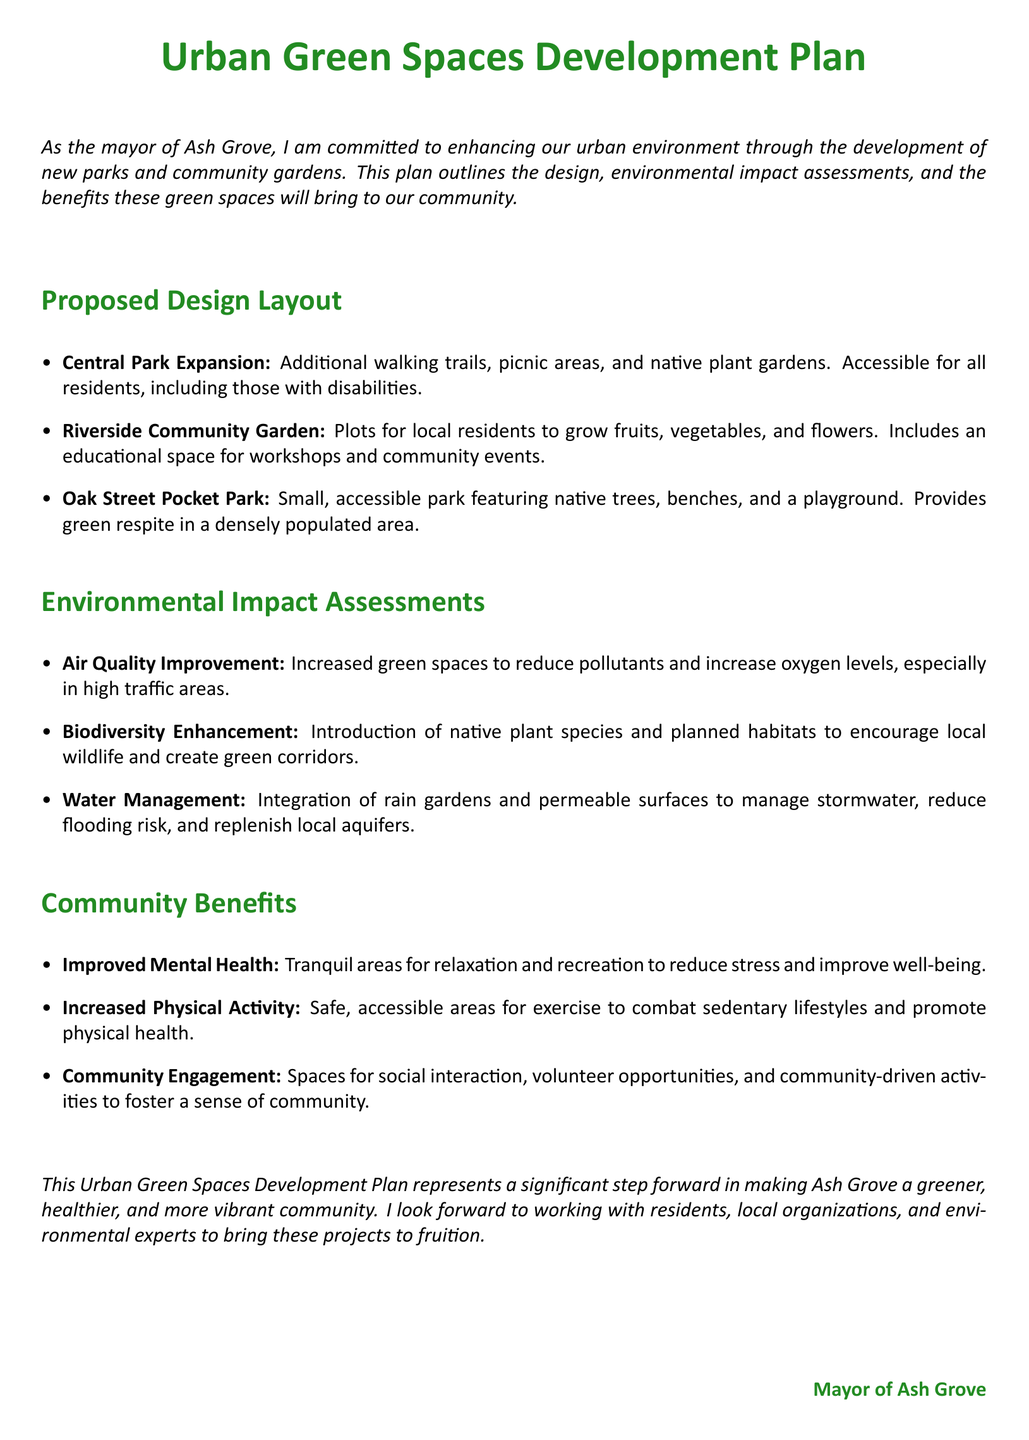What is the title of the document? The title is prominently displayed at the beginning, outlining the document's focus.
Answer: Urban Green Spaces Development Plan What is one feature of the Central Park Expansion? The document lists several features as part of the park expansion plan.
Answer: Additional walking trails How many parks are mentioned in the proposed design layout? Three parks are explicitly mentioned in the design layout section.
Answer: Three What type of plant species will be introduced for biodiversity enhancement? The document specifies the type of plants meant to support local ecosystems.
Answer: Native plant species What benefit is associated with increased physical activity? The document directly states the purpose of creating accessible areas for exercise.
Answer: Promote physical health What is one example of water management mentioned? The document includes specific strategies for managing stormwater and enhancing sustainability.
Answer: Rain gardens Which park is described as featuring a playground? The description highlights specific attributes of the parks mentioned in the layout.
Answer: Oak Street Pocket Park What are community gardens intended for? The purpose of community gardens is clearly stated in relation to local residents.
Answer: Grow fruits, vegetables, and flowers What is a key goal of the Urban Green Spaces Development Plan? The document outlines the overall intent behind the development plan for the community.
Answer: Enhance urban environment 